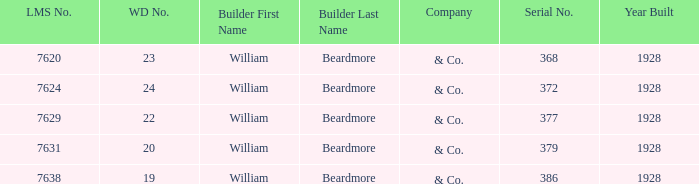Name the total number of wd number for lms number being 7638 1.0. 